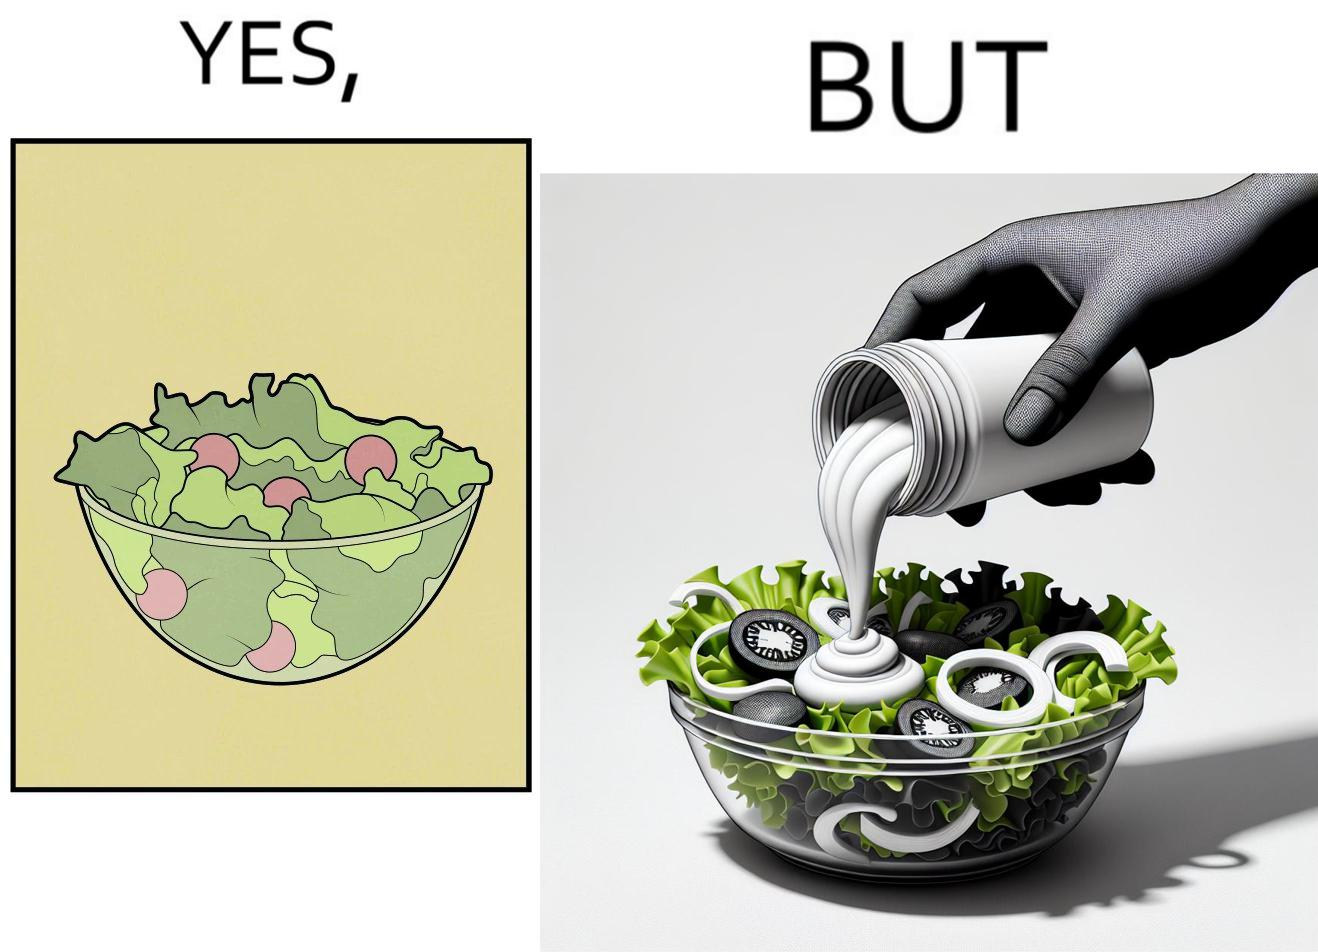Compare the left and right sides of this image. In the left part of the image: salad in a bowl In the right part of the image: pouring mayonnaise sauce on salad in a bowl 